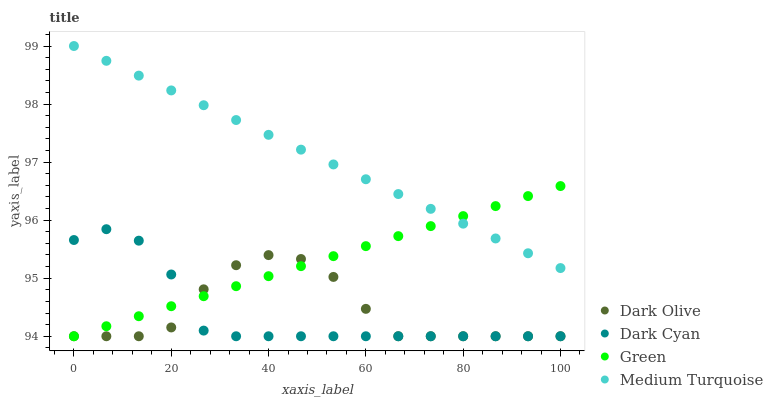Does Dark Cyan have the minimum area under the curve?
Answer yes or no. Yes. Does Medium Turquoise have the maximum area under the curve?
Answer yes or no. Yes. Does Dark Olive have the minimum area under the curve?
Answer yes or no. No. Does Dark Olive have the maximum area under the curve?
Answer yes or no. No. Is Green the smoothest?
Answer yes or no. Yes. Is Dark Olive the roughest?
Answer yes or no. Yes. Is Dark Olive the smoothest?
Answer yes or no. No. Is Green the roughest?
Answer yes or no. No. Does Dark Cyan have the lowest value?
Answer yes or no. Yes. Does Medium Turquoise have the lowest value?
Answer yes or no. No. Does Medium Turquoise have the highest value?
Answer yes or no. Yes. Does Green have the highest value?
Answer yes or no. No. Is Dark Olive less than Medium Turquoise?
Answer yes or no. Yes. Is Medium Turquoise greater than Dark Olive?
Answer yes or no. Yes. Does Dark Olive intersect Dark Cyan?
Answer yes or no. Yes. Is Dark Olive less than Dark Cyan?
Answer yes or no. No. Is Dark Olive greater than Dark Cyan?
Answer yes or no. No. Does Dark Olive intersect Medium Turquoise?
Answer yes or no. No. 